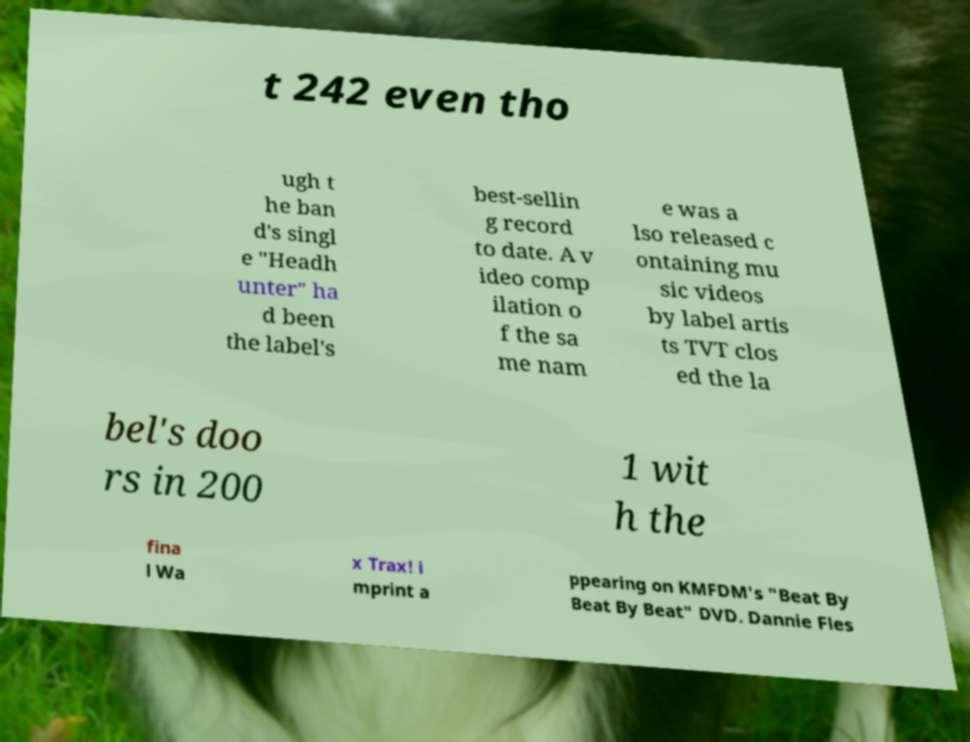I need the written content from this picture converted into text. Can you do that? t 242 even tho ugh t he ban d's singl e "Headh unter" ha d been the label's best-sellin g record to date. A v ideo comp ilation o f the sa me nam e was a lso released c ontaining mu sic videos by label artis ts TVT clos ed the la bel's doo rs in 200 1 wit h the fina l Wa x Trax! i mprint a ppearing on KMFDM's "Beat By Beat By Beat" DVD. Dannie Fles 